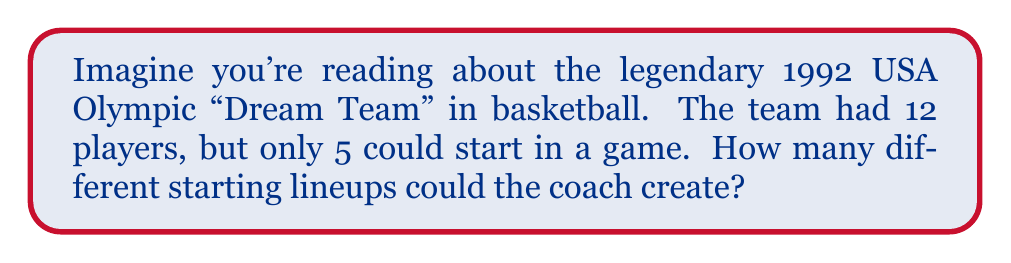What is the answer to this math problem? Let's approach this step-by-step:

1) This is a combination problem. We're selecting 5 players from a group of 12, where the order doesn't matter (it doesn't matter which position each player takes, just who's in the starting lineup).

2) The formula for combinations is:

   $${n \choose k} = \frac{n!}{k!(n-k)!}$$

   Where $n$ is the total number of items to choose from, and $k$ is the number of items being chosen.

3) In this case, $n = 12$ (total players) and $k = 5$ (players in the starting lineup).

4) Plugging these numbers into our formula:

   $${12 \choose 5} = \frac{12!}{5!(12-5)!} = \frac{12!}{5!(7)!}$$

5) Let's calculate this step-by-step:
   
   $$\frac{12 * 11 * 10 * 9 * 8 * 7!}{(5 * 4 * 3 * 2 * 1) * 7!}$$

6) The 7! cancels out in the numerator and denominator:

   $$\frac{12 * 11 * 10 * 9 * 8}{5 * 4 * 3 * 2 * 1} = \frac{95040}{120} = 792$$

Therefore, the coach could create 792 different starting lineups.
Answer: 792 different starting lineups 